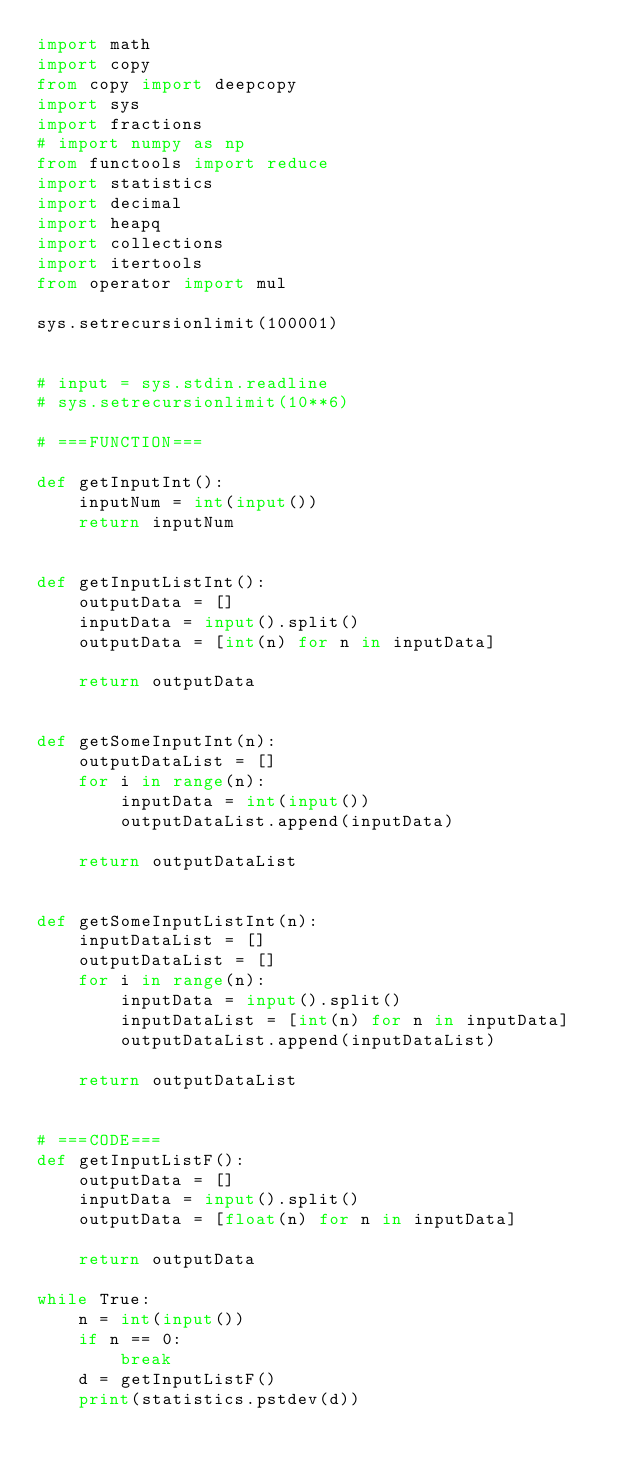Convert code to text. <code><loc_0><loc_0><loc_500><loc_500><_Python_>import math
import copy
from copy import deepcopy
import sys
import fractions
# import numpy as np
from functools import reduce
import statistics
import decimal
import heapq
import collections
import itertools
from operator import mul

sys.setrecursionlimit(100001)


# input = sys.stdin.readline
# sys.setrecursionlimit(10**6)

# ===FUNCTION===

def getInputInt():
    inputNum = int(input())
    return inputNum


def getInputListInt():
    outputData = []
    inputData = input().split()
    outputData = [int(n) for n in inputData]

    return outputData


def getSomeInputInt(n):
    outputDataList = []
    for i in range(n):
        inputData = int(input())
        outputDataList.append(inputData)

    return outputDataList


def getSomeInputListInt(n):
    inputDataList = []
    outputDataList = []
    for i in range(n):
        inputData = input().split()
        inputDataList = [int(n) for n in inputData]
        outputDataList.append(inputDataList)

    return outputDataList


# ===CODE===
def getInputListF():
    outputData = []
    inputData = input().split()
    outputData = [float(n) for n in inputData]

    return outputData

while True:
    n = int(input())
    if n == 0:
        break
    d = getInputListF()
    print(statistics.pstdev(d))
</code> 